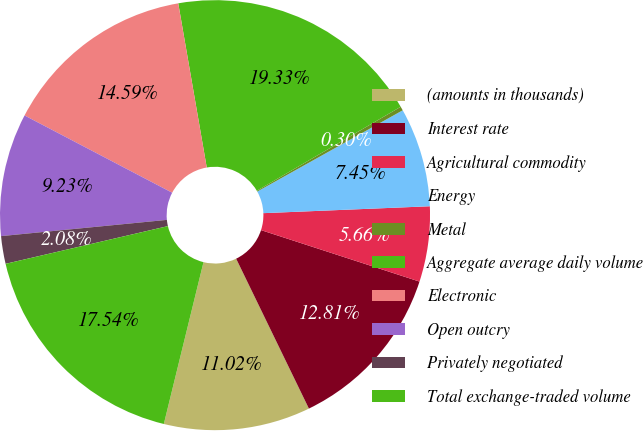Convert chart. <chart><loc_0><loc_0><loc_500><loc_500><pie_chart><fcel>(amounts in thousands)<fcel>Interest rate<fcel>Agricultural commodity<fcel>Energy<fcel>Metal<fcel>Aggregate average daily volume<fcel>Electronic<fcel>Open outcry<fcel>Privately negotiated<fcel>Total exchange-traded volume<nl><fcel>11.02%<fcel>12.81%<fcel>5.66%<fcel>7.45%<fcel>0.3%<fcel>19.33%<fcel>14.59%<fcel>9.23%<fcel>2.08%<fcel>17.54%<nl></chart> 